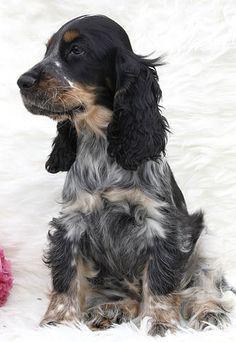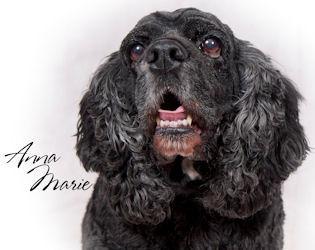The first image is the image on the left, the second image is the image on the right. Analyze the images presented: Is the assertion "in the right pic the dogs tongue can be seen" valid? Answer yes or no. Yes. 